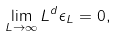Convert formula to latex. <formula><loc_0><loc_0><loc_500><loc_500>\lim _ { L \to \infty } L ^ { d } \epsilon _ { L } = 0 ,</formula> 